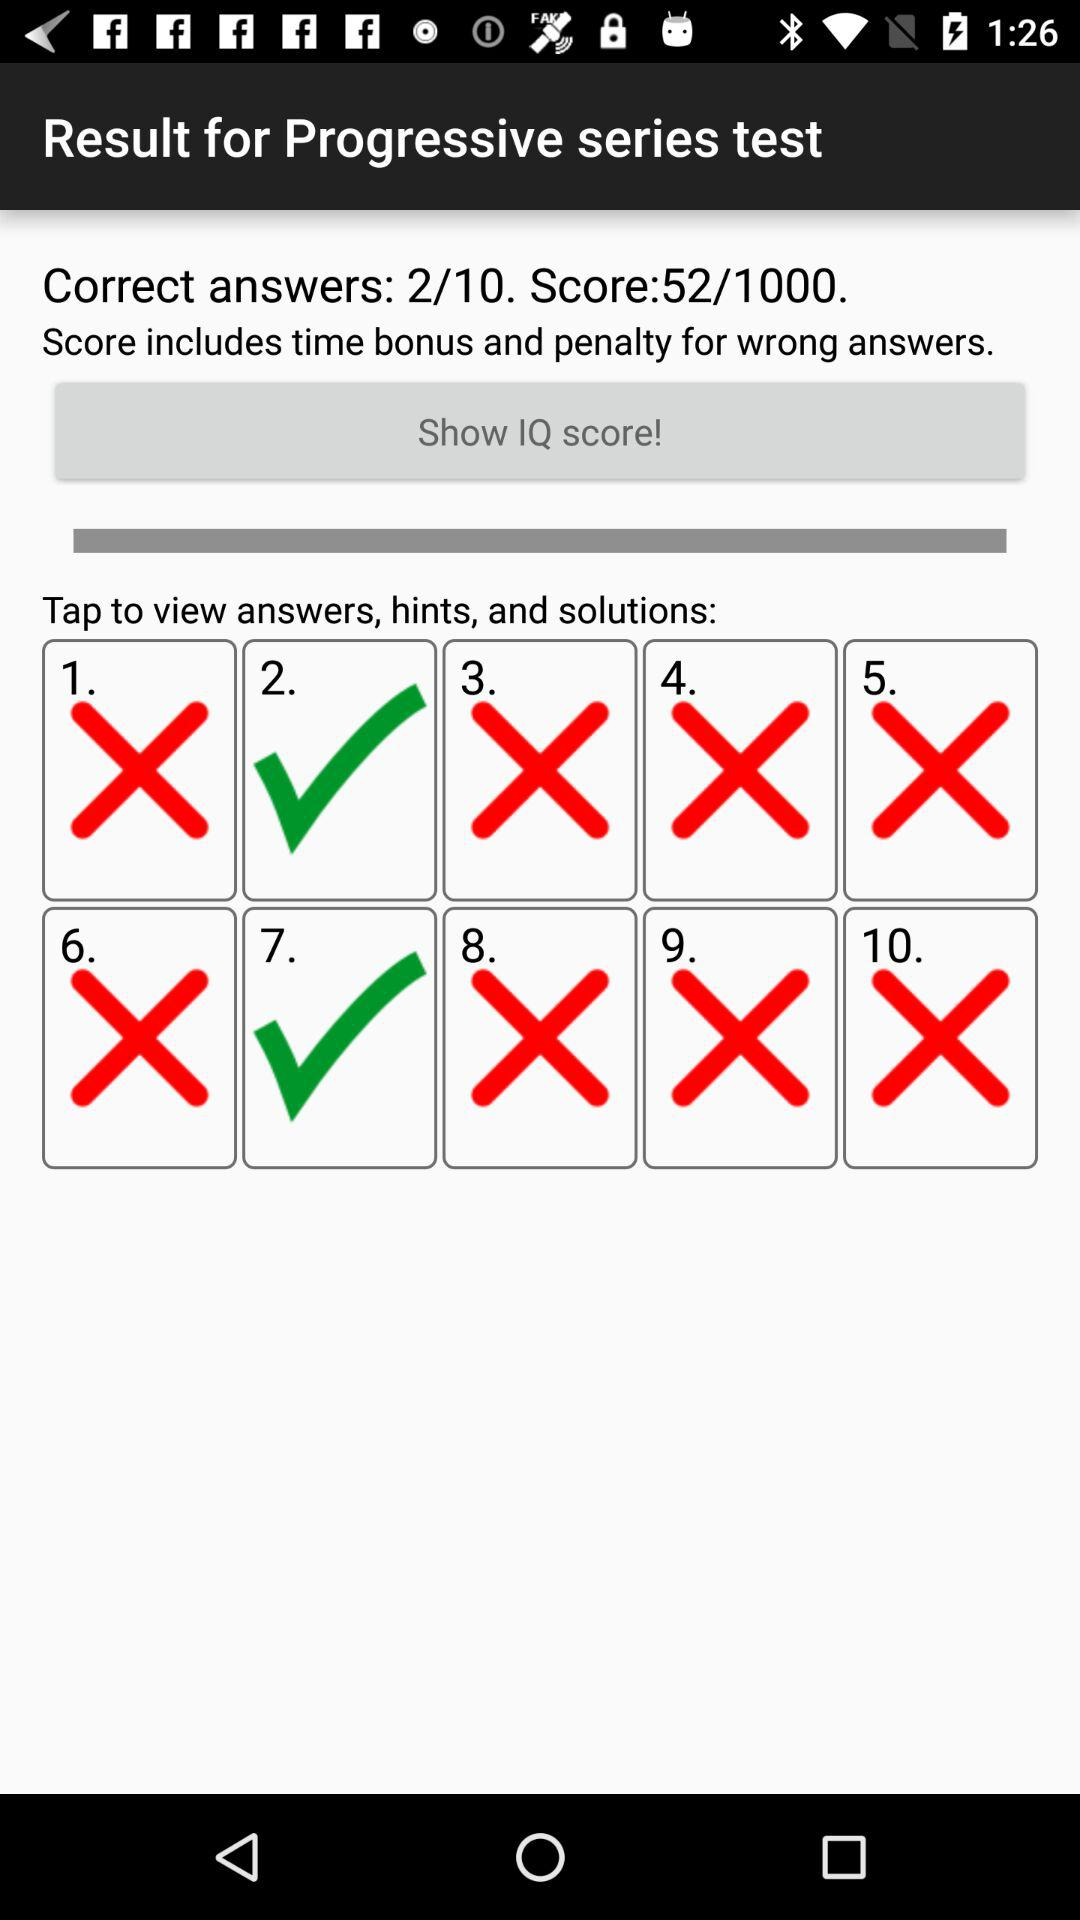What is the score? The score is 52/1000. 